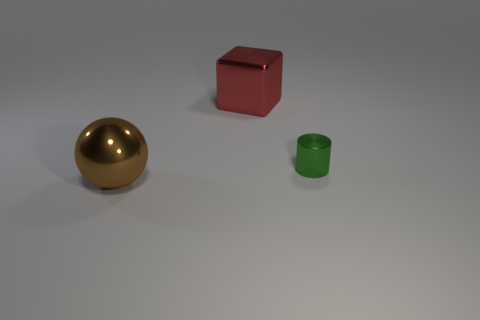Add 2 balls. How many objects exist? 5 Subtract all spheres. How many objects are left? 2 Subtract all small cylinders. Subtract all brown metallic objects. How many objects are left? 1 Add 3 big brown metallic things. How many big brown metallic things are left? 4 Add 1 big metal objects. How many big metal objects exist? 3 Subtract 0 red balls. How many objects are left? 3 